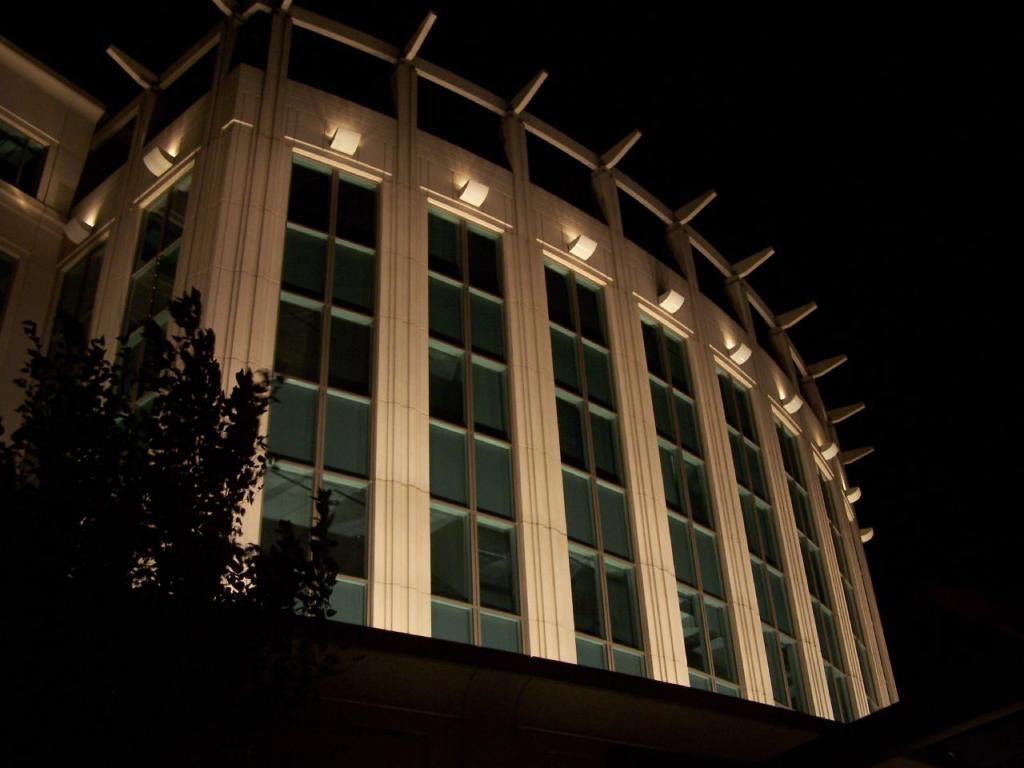What type of living organisms can be seen in the image? Plants can be seen in the image. What can be seen in the background of the image? There is a building in the background of the image. What is the color of the building? The building is white in color. What type of windows are visible in the image? There are glass windows visible in the image. What is present in the image that might provide illumination? Lights are present in the image. What is the color of the sky in the image? The sky appears to be black in color. What type of polish is being applied to the rabbits in the image? There are no rabbits present in the image, and therefore no polish is being applied. 